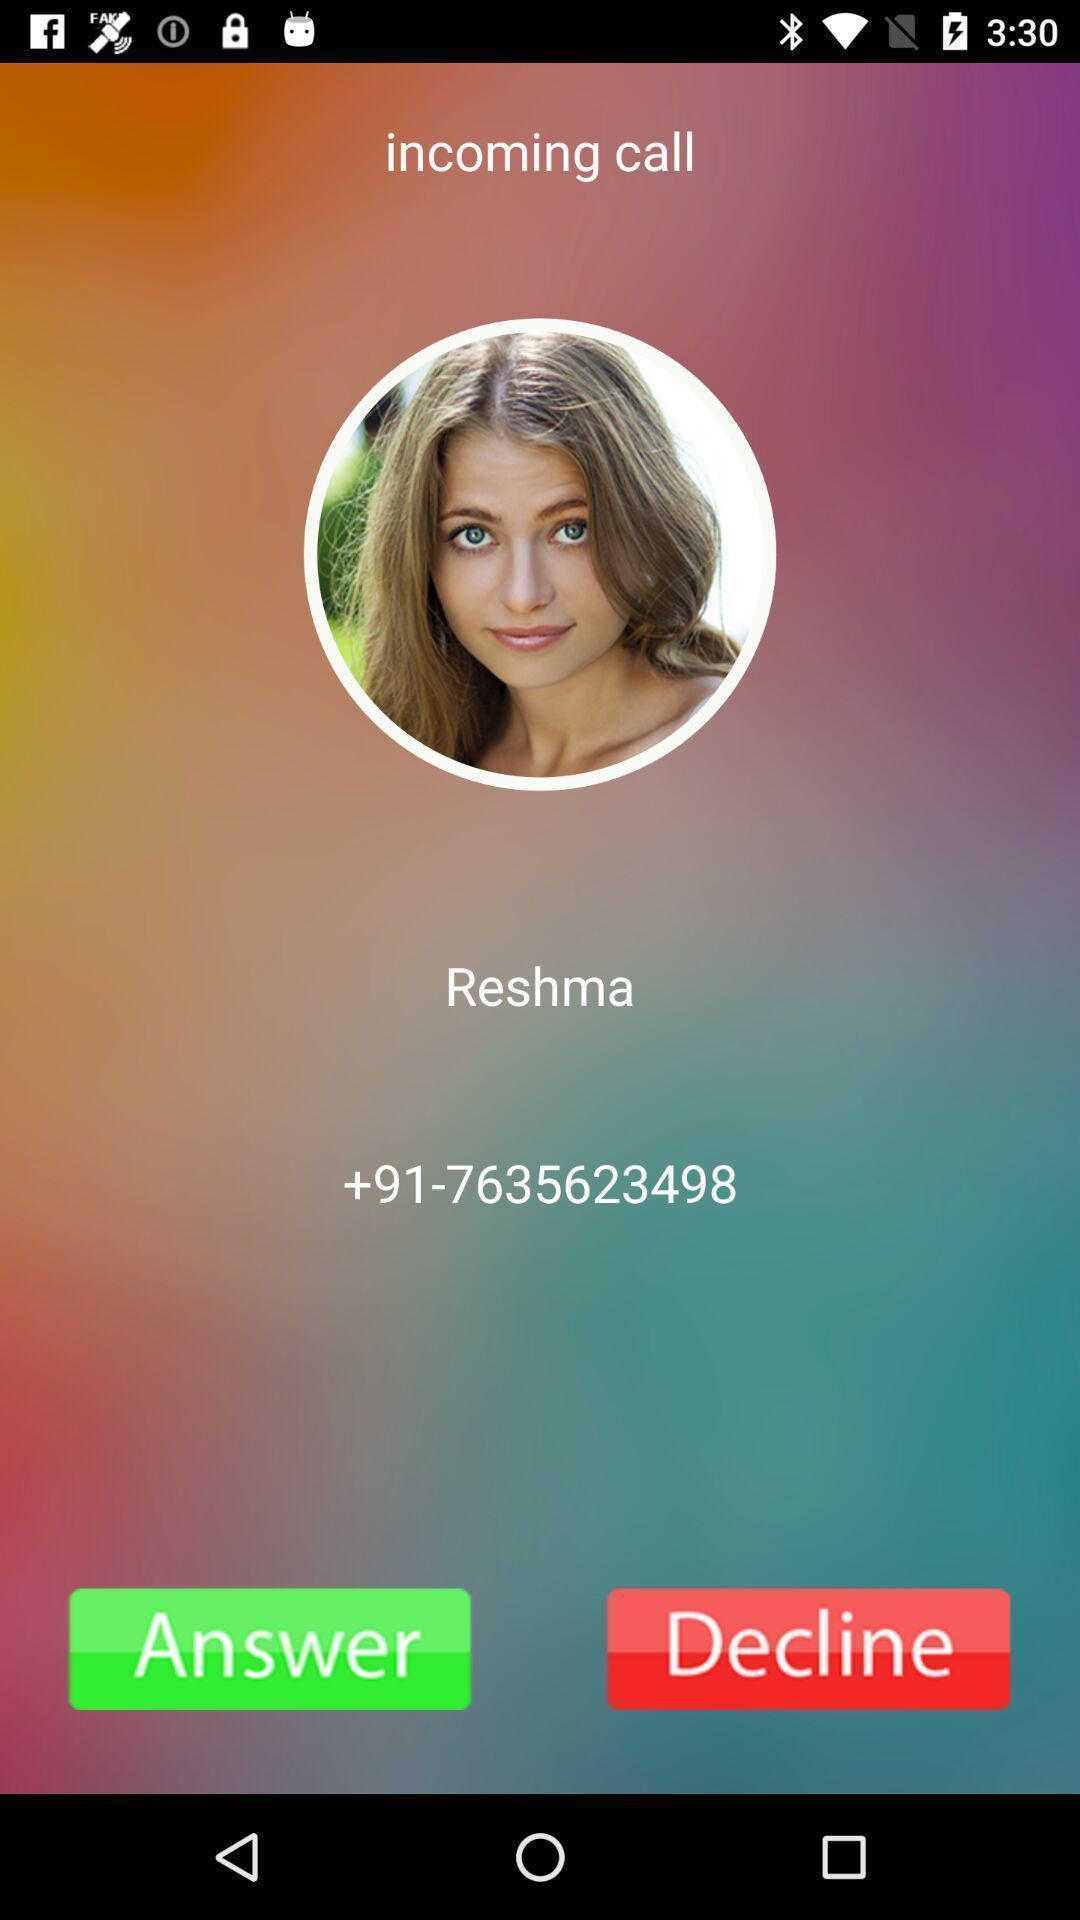What is the overall content of this screenshot? Screen shows incoming call details. 